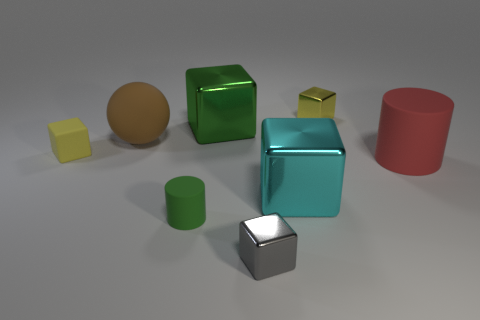Subtract all big green blocks. How many blocks are left? 4 Subtract 1 cubes. How many cubes are left? 4 Subtract all purple balls. How many yellow blocks are left? 2 Subtract all yellow blocks. How many blocks are left? 3 Add 2 small yellow rubber objects. How many objects exist? 10 Subtract all red cubes. Subtract all gray cylinders. How many cubes are left? 5 Subtract all cylinders. How many objects are left? 6 Add 1 big rubber spheres. How many big rubber spheres are left? 2 Add 1 gray cubes. How many gray cubes exist? 2 Subtract 0 brown blocks. How many objects are left? 8 